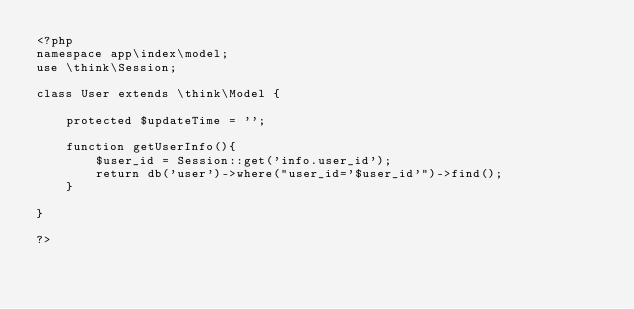Convert code to text. <code><loc_0><loc_0><loc_500><loc_500><_PHP_><?php
namespace app\index\model;
use \think\Session;

class User extends \think\Model {

	protected $updateTime = '';

	function getUserInfo(){
		$user_id = Session::get('info.user_id');
		return db('user')->where("user_id='$user_id'")->find();
	}

}

?></code> 